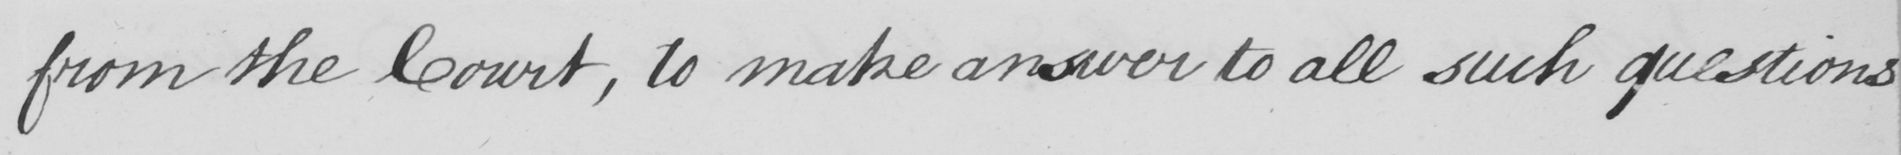What does this handwritten line say? from the Court , to make answer to all such questions 